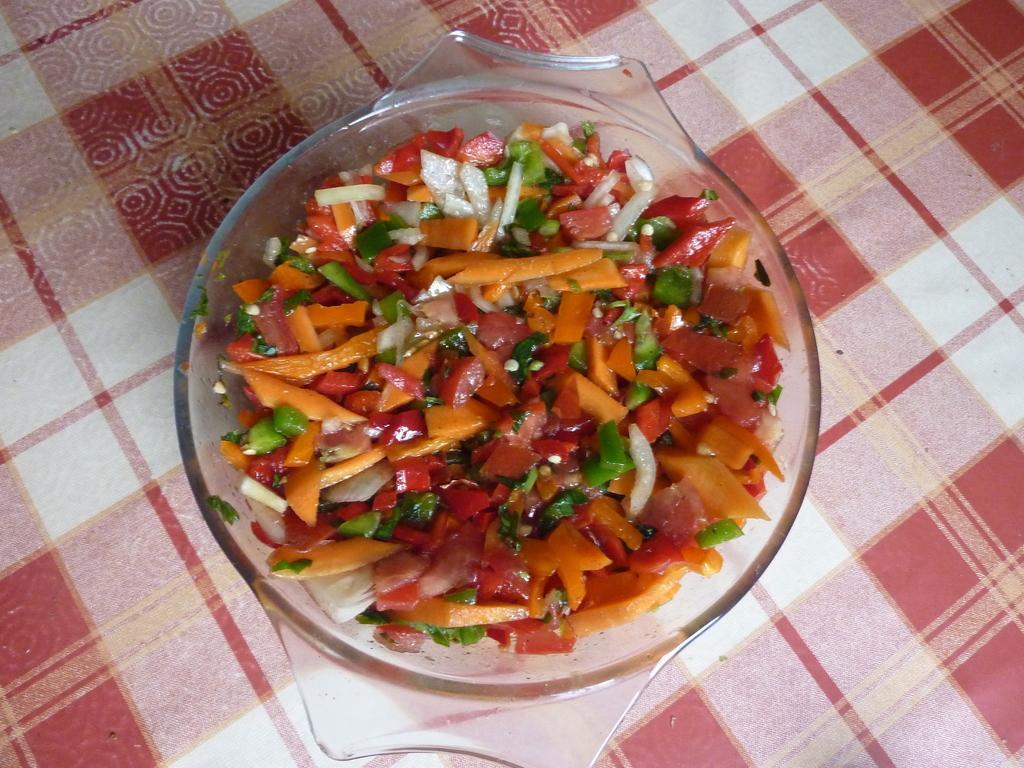Please provide a concise description of this image. In the center of the image there is a salad in bowl placed on the table. 